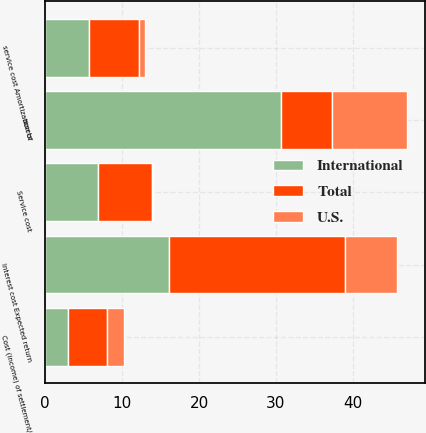Convert chart to OTSL. <chart><loc_0><loc_0><loc_500><loc_500><stacked_bar_chart><ecel><fcel>Service cost<fcel>Interest cost Expected return<fcel>assets<fcel>service cost Amortization of<fcel>Cost (income) of settlement/<nl><fcel>U.S.<fcel>0.1<fcel>6.8<fcel>9.8<fcel>0.8<fcel>2.1<nl><fcel>International<fcel>6.9<fcel>16.1<fcel>30.6<fcel>5.7<fcel>3<nl><fcel>Total<fcel>7<fcel>22.9<fcel>6.65<fcel>6.5<fcel>5.1<nl></chart> 